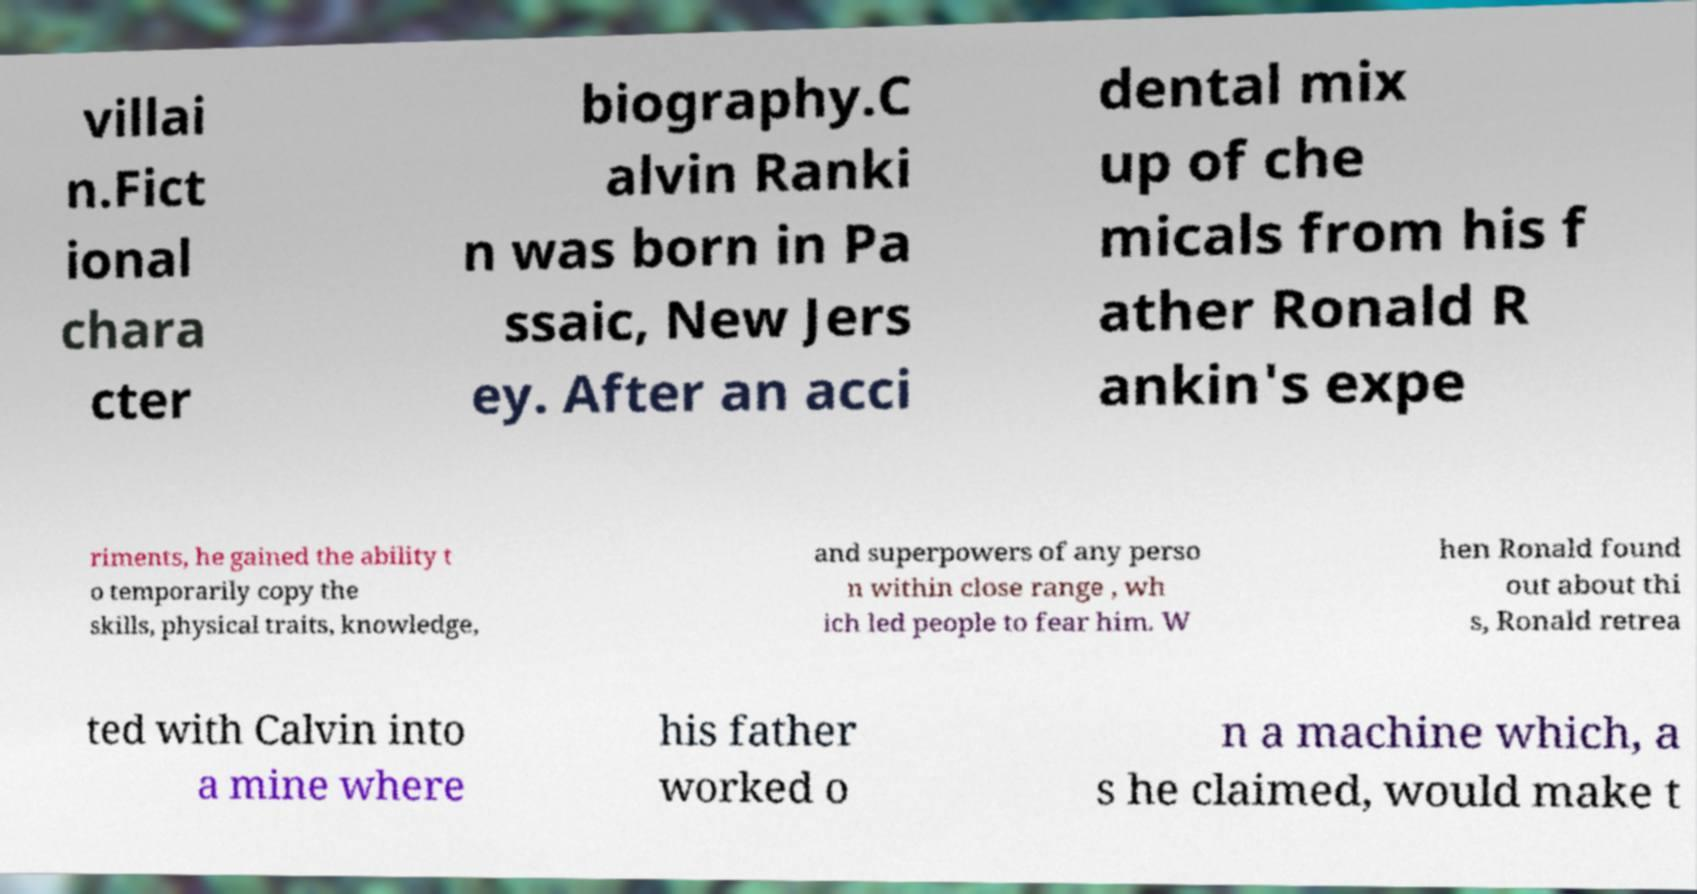Please identify and transcribe the text found in this image. villai n.Fict ional chara cter biography.C alvin Ranki n was born in Pa ssaic, New Jers ey. After an acci dental mix up of che micals from his f ather Ronald R ankin's expe riments, he gained the ability t o temporarily copy the skills, physical traits, knowledge, and superpowers of any perso n within close range , wh ich led people to fear him. W hen Ronald found out about thi s, Ronald retrea ted with Calvin into a mine where his father worked o n a machine which, a s he claimed, would make t 